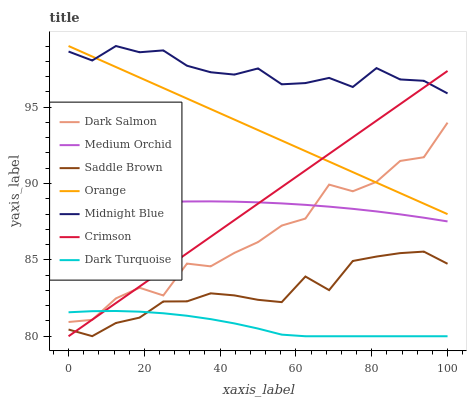Does Dark Turquoise have the minimum area under the curve?
Answer yes or no. Yes. Does Midnight Blue have the maximum area under the curve?
Answer yes or no. Yes. Does Medium Orchid have the minimum area under the curve?
Answer yes or no. No. Does Medium Orchid have the maximum area under the curve?
Answer yes or no. No. Is Crimson the smoothest?
Answer yes or no. Yes. Is Dark Salmon the roughest?
Answer yes or no. Yes. Is Dark Turquoise the smoothest?
Answer yes or no. No. Is Dark Turquoise the roughest?
Answer yes or no. No. Does Dark Turquoise have the lowest value?
Answer yes or no. Yes. Does Medium Orchid have the lowest value?
Answer yes or no. No. Does Orange have the highest value?
Answer yes or no. Yes. Does Medium Orchid have the highest value?
Answer yes or no. No. Is Dark Salmon less than Midnight Blue?
Answer yes or no. Yes. Is Orange greater than Dark Turquoise?
Answer yes or no. Yes. Does Orange intersect Midnight Blue?
Answer yes or no. Yes. Is Orange less than Midnight Blue?
Answer yes or no. No. Is Orange greater than Midnight Blue?
Answer yes or no. No. Does Dark Salmon intersect Midnight Blue?
Answer yes or no. No. 